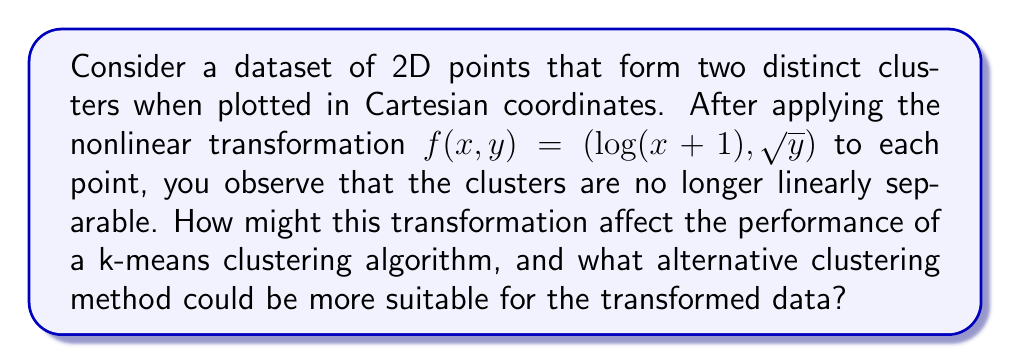Solve this math problem. To understand the impact of this nonlinear transformation on clustering algorithms, let's break down the problem step-by-step:

1. Initial dataset:
   The original dataset consists of two distinct clusters in 2D space, which are likely linearly separable.

2. Nonlinear transformation:
   The transformation $f(x, y) = (\log(x+1), \sqrt{y})$ is applied to each point.
   - The x-coordinate undergoes a logarithmic transformation.
   - The y-coordinate undergoes a square root transformation.

3. Effect of the transformation:
   - Logarithmic function compresses larger values more than smaller ones.
   - Square root function has a similar effect but less pronounced.
   - This can cause the clusters to become elongated or curved in the transformed space.

4. Impact on k-means clustering:
   K-means algorithm assumes:
   a) Clusters are spherical.
   b) Clusters have similar sizes.
   c) The variance of the distribution of each attribute is similar.

   The nonlinear transformation likely violates these assumptions by:
   - Creating non-spherical, possibly elongated or curved clusters.
   - Potentially changing the relative sizes of the clusters.
   - Altering the variance distribution of the attributes.

   As a result, k-means may:
   - Fail to identify the true cluster boundaries.
   - Split a single cluster into multiple parts.
   - Combine parts of different clusters incorrectly.

5. Alternative clustering method:
   A more suitable method for the transformed data could be density-based clustering algorithms, such as DBSCAN (Density-Based Spatial Clustering of Applications with Noise) or OPTICS (Ordering Points To Identify the Clustering Structure).

   Advantages of density-based methods:
   - Can identify clusters of arbitrary shape.
   - Do not assume spherical clusters or similar cluster sizes.
   - Can handle noise and outliers effectively.

   DBSCAN, in particular, would be well-suited because:
   - It can find arbitrarily shaped clusters.
   - It's less sensitive to the effects of nonlinear transformations.
   - It can identify core points, border points, and noise points, providing more insights into the cluster structure.
Answer: The nonlinear transformation is likely to negatively impact the performance of k-means clustering by violating its assumptions of spherical clusters with similar sizes and variance distributions. A density-based clustering algorithm like DBSCAN would be more suitable for the transformed data, as it can identify arbitrarily shaped clusters and is less sensitive to the effects of nonlinear transformations. 